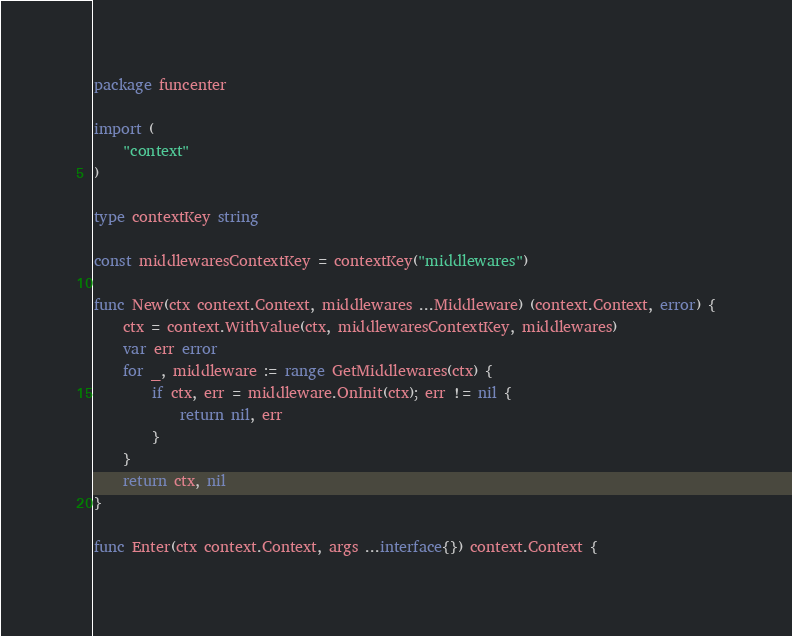<code> <loc_0><loc_0><loc_500><loc_500><_Go_>package funcenter

import (
	"context"
)

type contextKey string

const middlewaresContextKey = contextKey("middlewares")

func New(ctx context.Context, middlewares ...Middleware) (context.Context, error) {
	ctx = context.WithValue(ctx, middlewaresContextKey, middlewares)
	var err error
	for _, middleware := range GetMiddlewares(ctx) {
		if ctx, err = middleware.OnInit(ctx); err != nil {
			return nil, err
		}
	}
	return ctx, nil
}

func Enter(ctx context.Context, args ...interface{}) context.Context {</code> 